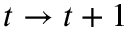<formula> <loc_0><loc_0><loc_500><loc_500>t \to t + 1</formula> 